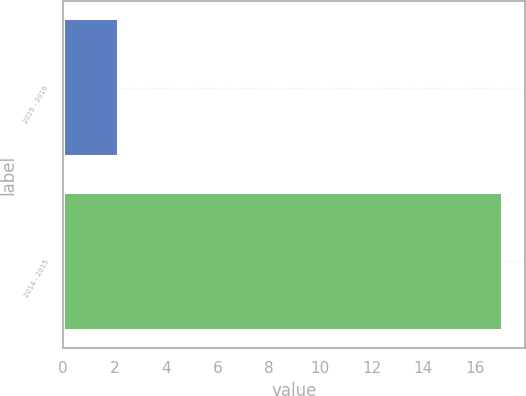<chart> <loc_0><loc_0><loc_500><loc_500><bar_chart><fcel>2015 - 2016<fcel>2014 - 2015<nl><fcel>2.2<fcel>17.1<nl></chart> 